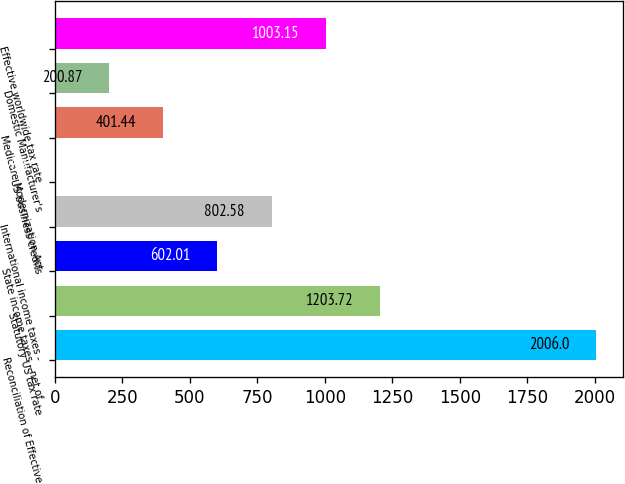<chart> <loc_0><loc_0><loc_500><loc_500><bar_chart><fcel>Reconciliation of Effective<fcel>Statutory US tax rate<fcel>State income taxes - net of<fcel>International income taxes -<fcel>US business credits<fcel>Medicare Modernization Act<fcel>Domestic Manufacturer's<fcel>Effective worldwide tax rate<nl><fcel>2006<fcel>1203.72<fcel>602.01<fcel>802.58<fcel>0.3<fcel>401.44<fcel>200.87<fcel>1003.15<nl></chart> 